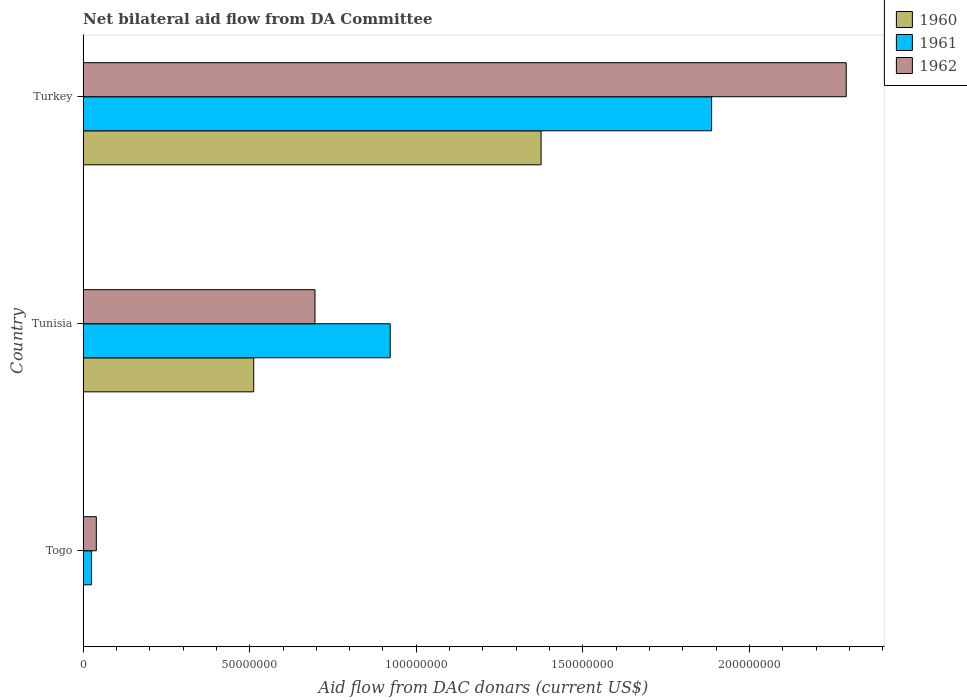How many groups of bars are there?
Keep it short and to the point. 3. Are the number of bars per tick equal to the number of legend labels?
Provide a succinct answer. Yes. What is the label of the 3rd group of bars from the top?
Offer a terse response. Togo. In how many cases, is the number of bars for a given country not equal to the number of legend labels?
Offer a very short reply. 0. What is the aid flow in in 1962 in Togo?
Make the answer very short. 3.96e+06. Across all countries, what is the maximum aid flow in in 1962?
Offer a terse response. 2.29e+08. Across all countries, what is the minimum aid flow in in 1960?
Your answer should be compact. 3.00e+04. In which country was the aid flow in in 1962 minimum?
Your response must be concise. Togo. What is the total aid flow in in 1961 in the graph?
Your answer should be very brief. 2.83e+08. What is the difference between the aid flow in in 1961 in Togo and that in Turkey?
Offer a terse response. -1.86e+08. What is the difference between the aid flow in in 1962 in Tunisia and the aid flow in in 1961 in Togo?
Your answer should be very brief. 6.71e+07. What is the average aid flow in in 1962 per country?
Your answer should be very brief. 1.01e+08. What is the difference between the aid flow in in 1961 and aid flow in in 1962 in Tunisia?
Offer a terse response. 2.26e+07. What is the ratio of the aid flow in in 1960 in Togo to that in Turkey?
Keep it short and to the point. 0. Is the difference between the aid flow in in 1961 in Tunisia and Turkey greater than the difference between the aid flow in in 1962 in Tunisia and Turkey?
Offer a very short reply. Yes. What is the difference between the highest and the second highest aid flow in in 1962?
Make the answer very short. 1.59e+08. What is the difference between the highest and the lowest aid flow in in 1962?
Keep it short and to the point. 2.25e+08. Is the sum of the aid flow in in 1961 in Tunisia and Turkey greater than the maximum aid flow in in 1960 across all countries?
Offer a very short reply. Yes. What does the 1st bar from the bottom in Turkey represents?
Your answer should be very brief. 1960. How many bars are there?
Provide a succinct answer. 9. Where does the legend appear in the graph?
Ensure brevity in your answer.  Top right. How many legend labels are there?
Provide a succinct answer. 3. How are the legend labels stacked?
Provide a short and direct response. Vertical. What is the title of the graph?
Provide a succinct answer. Net bilateral aid flow from DA Committee. Does "1966" appear as one of the legend labels in the graph?
Provide a short and direct response. No. What is the label or title of the X-axis?
Offer a terse response. Aid flow from DAC donars (current US$). What is the Aid flow from DAC donars (current US$) in 1960 in Togo?
Keep it short and to the point. 3.00e+04. What is the Aid flow from DAC donars (current US$) of 1961 in Togo?
Ensure brevity in your answer.  2.53e+06. What is the Aid flow from DAC donars (current US$) in 1962 in Togo?
Provide a short and direct response. 3.96e+06. What is the Aid flow from DAC donars (current US$) of 1960 in Tunisia?
Give a very brief answer. 5.12e+07. What is the Aid flow from DAC donars (current US$) in 1961 in Tunisia?
Your answer should be compact. 9.22e+07. What is the Aid flow from DAC donars (current US$) in 1962 in Tunisia?
Offer a very short reply. 6.96e+07. What is the Aid flow from DAC donars (current US$) in 1960 in Turkey?
Provide a short and direct response. 1.37e+08. What is the Aid flow from DAC donars (current US$) in 1961 in Turkey?
Make the answer very short. 1.89e+08. What is the Aid flow from DAC donars (current US$) of 1962 in Turkey?
Offer a terse response. 2.29e+08. Across all countries, what is the maximum Aid flow from DAC donars (current US$) in 1960?
Your answer should be compact. 1.37e+08. Across all countries, what is the maximum Aid flow from DAC donars (current US$) of 1961?
Your answer should be very brief. 1.89e+08. Across all countries, what is the maximum Aid flow from DAC donars (current US$) of 1962?
Offer a terse response. 2.29e+08. Across all countries, what is the minimum Aid flow from DAC donars (current US$) in 1961?
Your response must be concise. 2.53e+06. Across all countries, what is the minimum Aid flow from DAC donars (current US$) of 1962?
Your answer should be compact. 3.96e+06. What is the total Aid flow from DAC donars (current US$) of 1960 in the graph?
Your answer should be very brief. 1.89e+08. What is the total Aid flow from DAC donars (current US$) in 1961 in the graph?
Your response must be concise. 2.83e+08. What is the total Aid flow from DAC donars (current US$) of 1962 in the graph?
Offer a very short reply. 3.03e+08. What is the difference between the Aid flow from DAC donars (current US$) of 1960 in Togo and that in Tunisia?
Give a very brief answer. -5.12e+07. What is the difference between the Aid flow from DAC donars (current US$) of 1961 in Togo and that in Tunisia?
Offer a very short reply. -8.96e+07. What is the difference between the Aid flow from DAC donars (current US$) of 1962 in Togo and that in Tunisia?
Your answer should be compact. -6.56e+07. What is the difference between the Aid flow from DAC donars (current US$) of 1960 in Togo and that in Turkey?
Your answer should be compact. -1.37e+08. What is the difference between the Aid flow from DAC donars (current US$) in 1961 in Togo and that in Turkey?
Make the answer very short. -1.86e+08. What is the difference between the Aid flow from DAC donars (current US$) in 1962 in Togo and that in Turkey?
Give a very brief answer. -2.25e+08. What is the difference between the Aid flow from DAC donars (current US$) in 1960 in Tunisia and that in Turkey?
Offer a very short reply. -8.63e+07. What is the difference between the Aid flow from DAC donars (current US$) of 1961 in Tunisia and that in Turkey?
Your answer should be compact. -9.65e+07. What is the difference between the Aid flow from DAC donars (current US$) in 1962 in Tunisia and that in Turkey?
Your response must be concise. -1.59e+08. What is the difference between the Aid flow from DAC donars (current US$) of 1960 in Togo and the Aid flow from DAC donars (current US$) of 1961 in Tunisia?
Offer a terse response. -9.21e+07. What is the difference between the Aid flow from DAC donars (current US$) of 1960 in Togo and the Aid flow from DAC donars (current US$) of 1962 in Tunisia?
Provide a succinct answer. -6.96e+07. What is the difference between the Aid flow from DAC donars (current US$) of 1961 in Togo and the Aid flow from DAC donars (current US$) of 1962 in Tunisia?
Make the answer very short. -6.71e+07. What is the difference between the Aid flow from DAC donars (current US$) of 1960 in Togo and the Aid flow from DAC donars (current US$) of 1961 in Turkey?
Offer a very short reply. -1.89e+08. What is the difference between the Aid flow from DAC donars (current US$) in 1960 in Togo and the Aid flow from DAC donars (current US$) in 1962 in Turkey?
Provide a short and direct response. -2.29e+08. What is the difference between the Aid flow from DAC donars (current US$) of 1961 in Togo and the Aid flow from DAC donars (current US$) of 1962 in Turkey?
Offer a terse response. -2.26e+08. What is the difference between the Aid flow from DAC donars (current US$) in 1960 in Tunisia and the Aid flow from DAC donars (current US$) in 1961 in Turkey?
Your answer should be very brief. -1.37e+08. What is the difference between the Aid flow from DAC donars (current US$) in 1960 in Tunisia and the Aid flow from DAC donars (current US$) in 1962 in Turkey?
Ensure brevity in your answer.  -1.78e+08. What is the difference between the Aid flow from DAC donars (current US$) in 1961 in Tunisia and the Aid flow from DAC donars (current US$) in 1962 in Turkey?
Give a very brief answer. -1.37e+08. What is the average Aid flow from DAC donars (current US$) in 1960 per country?
Your response must be concise. 6.29e+07. What is the average Aid flow from DAC donars (current US$) in 1961 per country?
Your answer should be compact. 9.44e+07. What is the average Aid flow from DAC donars (current US$) in 1962 per country?
Ensure brevity in your answer.  1.01e+08. What is the difference between the Aid flow from DAC donars (current US$) of 1960 and Aid flow from DAC donars (current US$) of 1961 in Togo?
Provide a short and direct response. -2.50e+06. What is the difference between the Aid flow from DAC donars (current US$) of 1960 and Aid flow from DAC donars (current US$) of 1962 in Togo?
Ensure brevity in your answer.  -3.93e+06. What is the difference between the Aid flow from DAC donars (current US$) of 1961 and Aid flow from DAC donars (current US$) of 1962 in Togo?
Provide a succinct answer. -1.43e+06. What is the difference between the Aid flow from DAC donars (current US$) of 1960 and Aid flow from DAC donars (current US$) of 1961 in Tunisia?
Your response must be concise. -4.10e+07. What is the difference between the Aid flow from DAC donars (current US$) of 1960 and Aid flow from DAC donars (current US$) of 1962 in Tunisia?
Offer a terse response. -1.84e+07. What is the difference between the Aid flow from DAC donars (current US$) of 1961 and Aid flow from DAC donars (current US$) of 1962 in Tunisia?
Your answer should be compact. 2.26e+07. What is the difference between the Aid flow from DAC donars (current US$) of 1960 and Aid flow from DAC donars (current US$) of 1961 in Turkey?
Your answer should be very brief. -5.12e+07. What is the difference between the Aid flow from DAC donars (current US$) in 1960 and Aid flow from DAC donars (current US$) in 1962 in Turkey?
Your response must be concise. -9.16e+07. What is the difference between the Aid flow from DAC donars (current US$) in 1961 and Aid flow from DAC donars (current US$) in 1962 in Turkey?
Keep it short and to the point. -4.04e+07. What is the ratio of the Aid flow from DAC donars (current US$) of 1960 in Togo to that in Tunisia?
Make the answer very short. 0. What is the ratio of the Aid flow from DAC donars (current US$) of 1961 in Togo to that in Tunisia?
Keep it short and to the point. 0.03. What is the ratio of the Aid flow from DAC donars (current US$) of 1962 in Togo to that in Tunisia?
Your answer should be compact. 0.06. What is the ratio of the Aid flow from DAC donars (current US$) of 1961 in Togo to that in Turkey?
Ensure brevity in your answer.  0.01. What is the ratio of the Aid flow from DAC donars (current US$) of 1962 in Togo to that in Turkey?
Make the answer very short. 0.02. What is the ratio of the Aid flow from DAC donars (current US$) of 1960 in Tunisia to that in Turkey?
Offer a terse response. 0.37. What is the ratio of the Aid flow from DAC donars (current US$) of 1961 in Tunisia to that in Turkey?
Your response must be concise. 0.49. What is the ratio of the Aid flow from DAC donars (current US$) in 1962 in Tunisia to that in Turkey?
Keep it short and to the point. 0.3. What is the difference between the highest and the second highest Aid flow from DAC donars (current US$) in 1960?
Provide a succinct answer. 8.63e+07. What is the difference between the highest and the second highest Aid flow from DAC donars (current US$) in 1961?
Keep it short and to the point. 9.65e+07. What is the difference between the highest and the second highest Aid flow from DAC donars (current US$) in 1962?
Your answer should be very brief. 1.59e+08. What is the difference between the highest and the lowest Aid flow from DAC donars (current US$) of 1960?
Provide a short and direct response. 1.37e+08. What is the difference between the highest and the lowest Aid flow from DAC donars (current US$) in 1961?
Provide a short and direct response. 1.86e+08. What is the difference between the highest and the lowest Aid flow from DAC donars (current US$) of 1962?
Ensure brevity in your answer.  2.25e+08. 